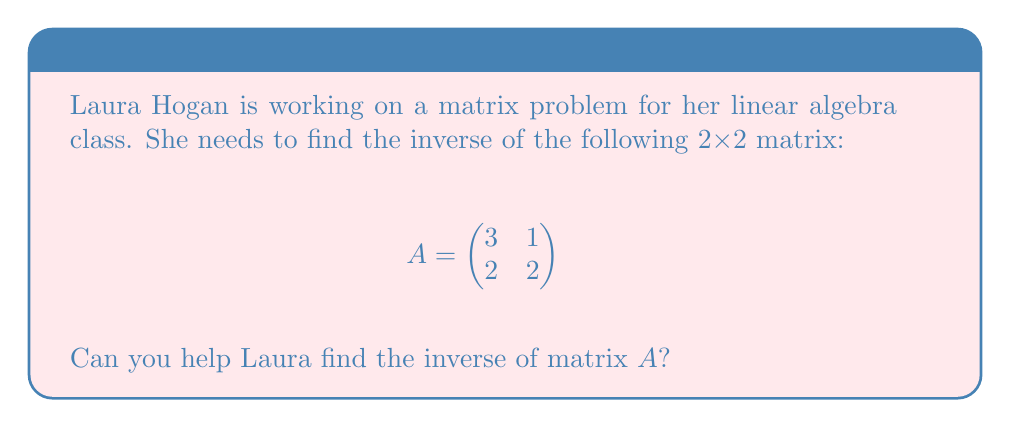Can you answer this question? To find the inverse of a 2x2 matrix, we can follow these steps:

1. Calculate the determinant of A:
   $det(A) = (3 \times 2) - (1 \times 2) = 6 - 2 = 4$

2. Check if the matrix is invertible:
   Since $det(A) \neq 0$, the matrix is invertible.

3. Find the adjugate matrix:
   $$adj(A) = \begin{pmatrix}
   2 & -1 \\
   -2 & 3
   \end{pmatrix}$$

4. Calculate the inverse using the formula:
   $$A^{-1} = \frac{1}{det(A)} \times adj(A)$$

   $$A^{-1} = \frac{1}{4} \times \begin{pmatrix}
   2 & -1 \\
   -2 & 3
   \end{pmatrix}$$

5. Simplify:
   $$A^{-1} = \begin{pmatrix}
   \frac{1}{2} & -\frac{1}{4} \\
   -\frac{1}{2} & \frac{3}{4}
   \end{pmatrix}$$
Answer: $$A^{-1} = \begin{pmatrix}
\frac{1}{2} & -\frac{1}{4} \\
-\frac{1}{2} & \frac{3}{4}
\end{pmatrix}$$ 